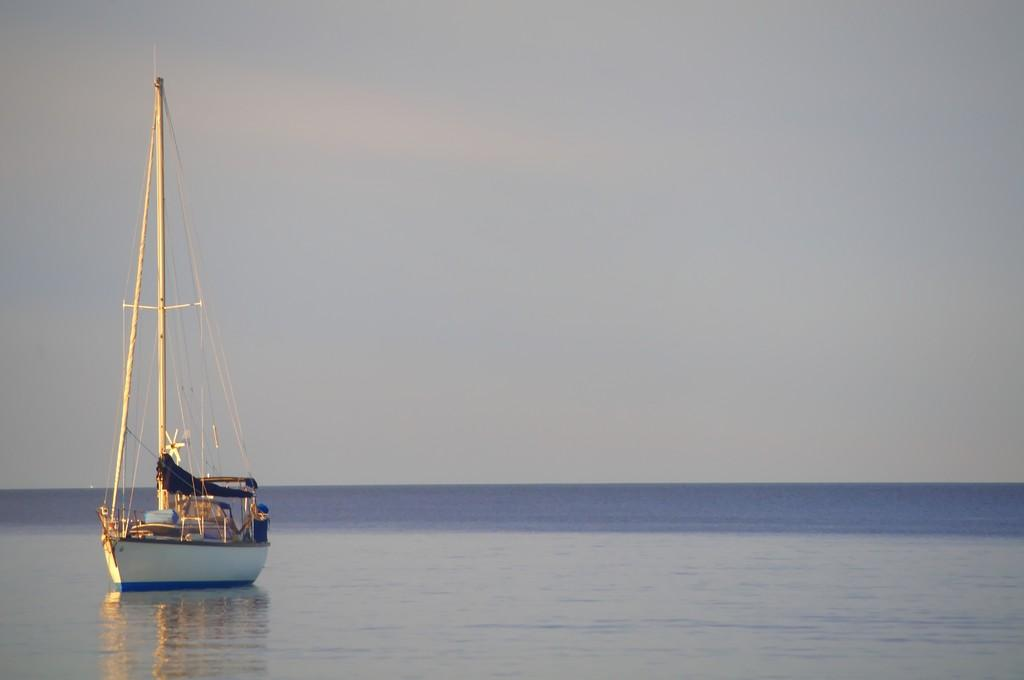What is the main subject of the image? The main subject of the image is a boat. Where is the boat located? The boat is on water. What else can be seen on the boat? There are objects on the boat. What can be seen in the background of the image? The sky is visible in the background of the image. What type of discussion is taking place on the boat in the image? There is no discussion taking place on the boat in the image; it only shows the boat on water with objects on it. How many bikes are visible on the boat in the image? There are no bikes visible on the boat in the image. 